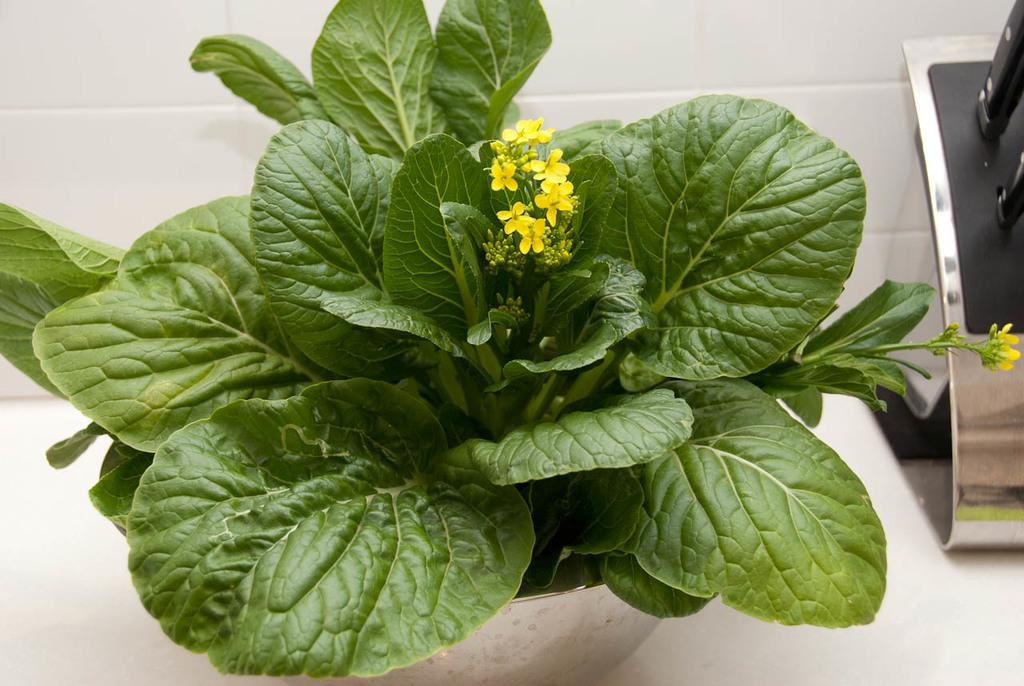What type of living organisms can be seen in the image? Plants can be seen in the image. What color are the flowers on the plants? The flowers on the plants are yellow. What type of corn can be seen growing in the image? There is no corn present in the image; it features plants with yellow flowers. What activity are the plants participating in within the image? The plants are not participating in any activity; they are simply growing and displaying their yellow flowers. 